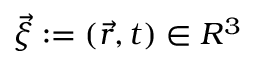<formula> <loc_0><loc_0><loc_500><loc_500>\vec { \xi } \colon = ( \vec { r } , t ) \in R ^ { 3 }</formula> 